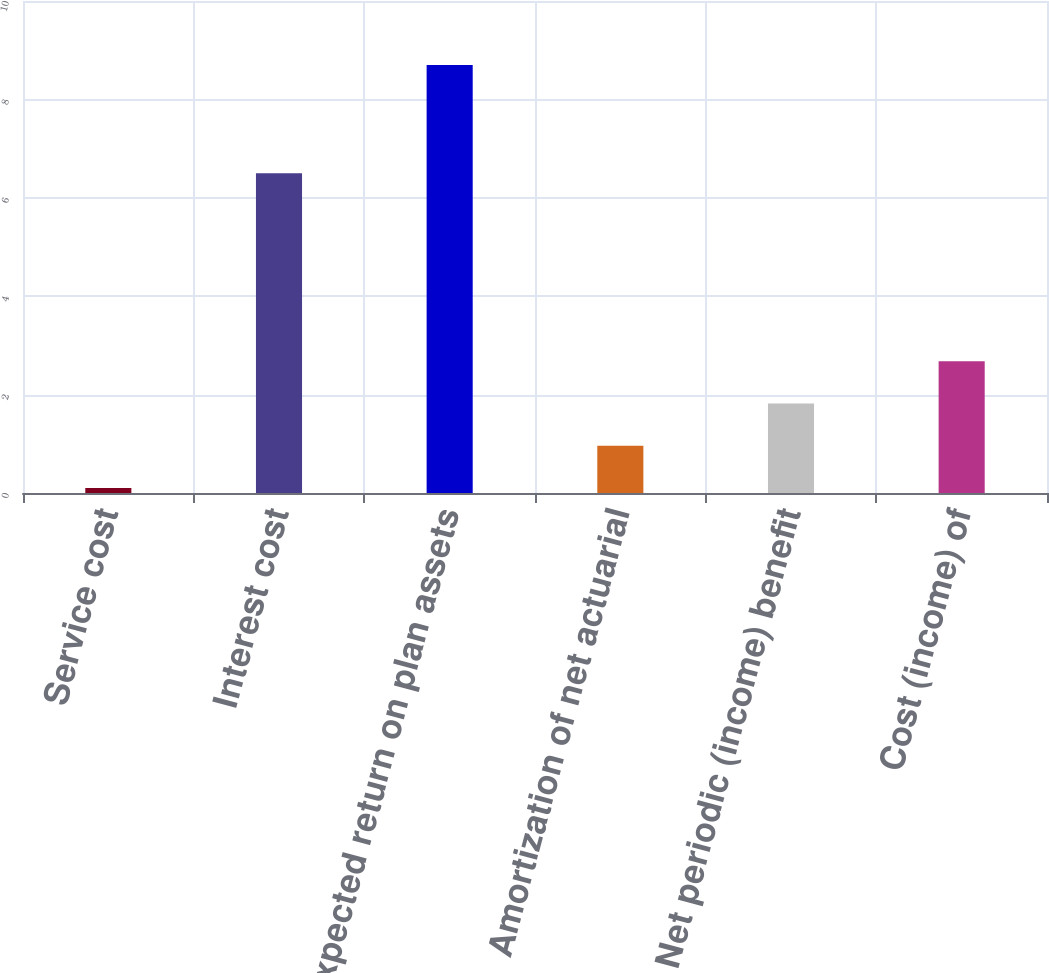Convert chart to OTSL. <chart><loc_0><loc_0><loc_500><loc_500><bar_chart><fcel>Service cost<fcel>Interest cost<fcel>Expected return on plan assets<fcel>Amortization of net actuarial<fcel>Net periodic (income) benefit<fcel>Cost (income) of<nl><fcel>0.1<fcel>6.5<fcel>8.7<fcel>0.96<fcel>1.82<fcel>2.68<nl></chart> 